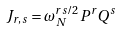Convert formula to latex. <formula><loc_0><loc_0><loc_500><loc_500>J _ { r , s } = \omega _ { N } ^ { r s / 2 } P ^ { r } Q ^ { s }</formula> 